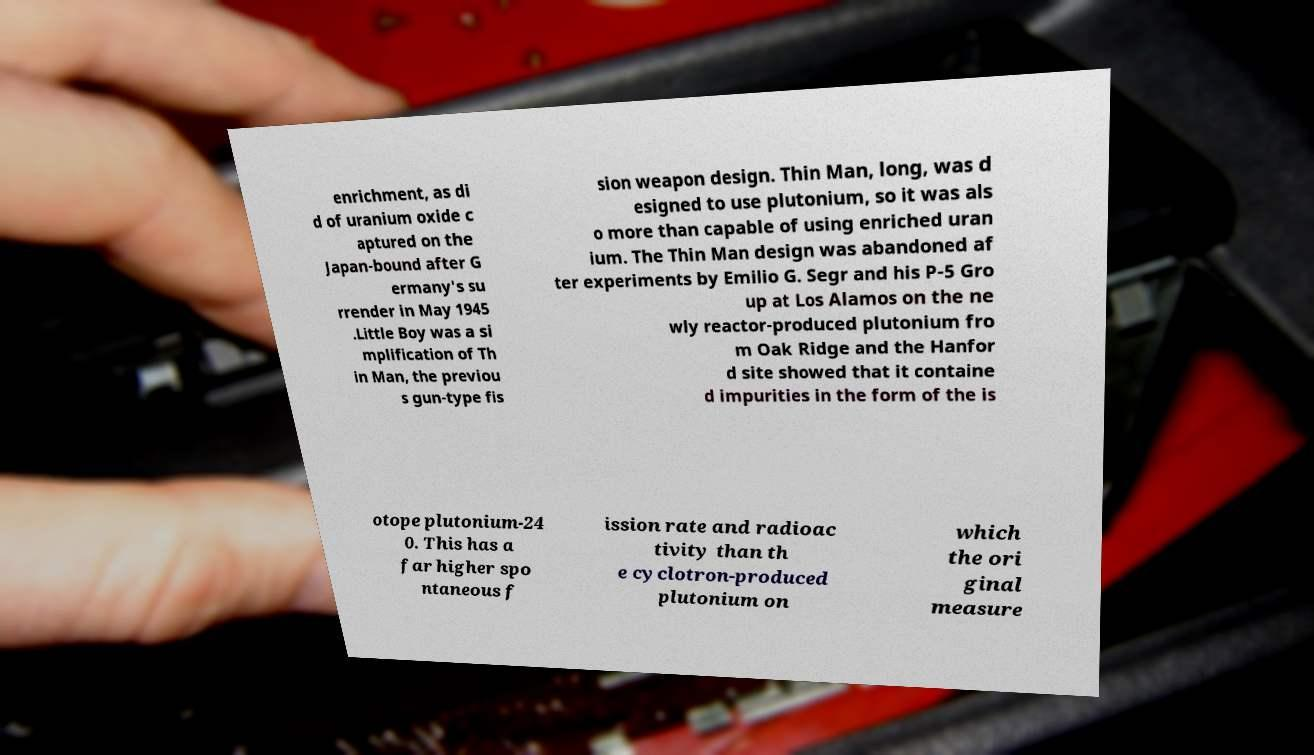Could you assist in decoding the text presented in this image and type it out clearly? enrichment, as di d of uranium oxide c aptured on the Japan-bound after G ermany's su rrender in May 1945 .Little Boy was a si mplification of Th in Man, the previou s gun-type fis sion weapon design. Thin Man, long, was d esigned to use plutonium, so it was als o more than capable of using enriched uran ium. The Thin Man design was abandoned af ter experiments by Emilio G. Segr and his P-5 Gro up at Los Alamos on the ne wly reactor-produced plutonium fro m Oak Ridge and the Hanfor d site showed that it containe d impurities in the form of the is otope plutonium-24 0. This has a far higher spo ntaneous f ission rate and radioac tivity than th e cyclotron-produced plutonium on which the ori ginal measure 